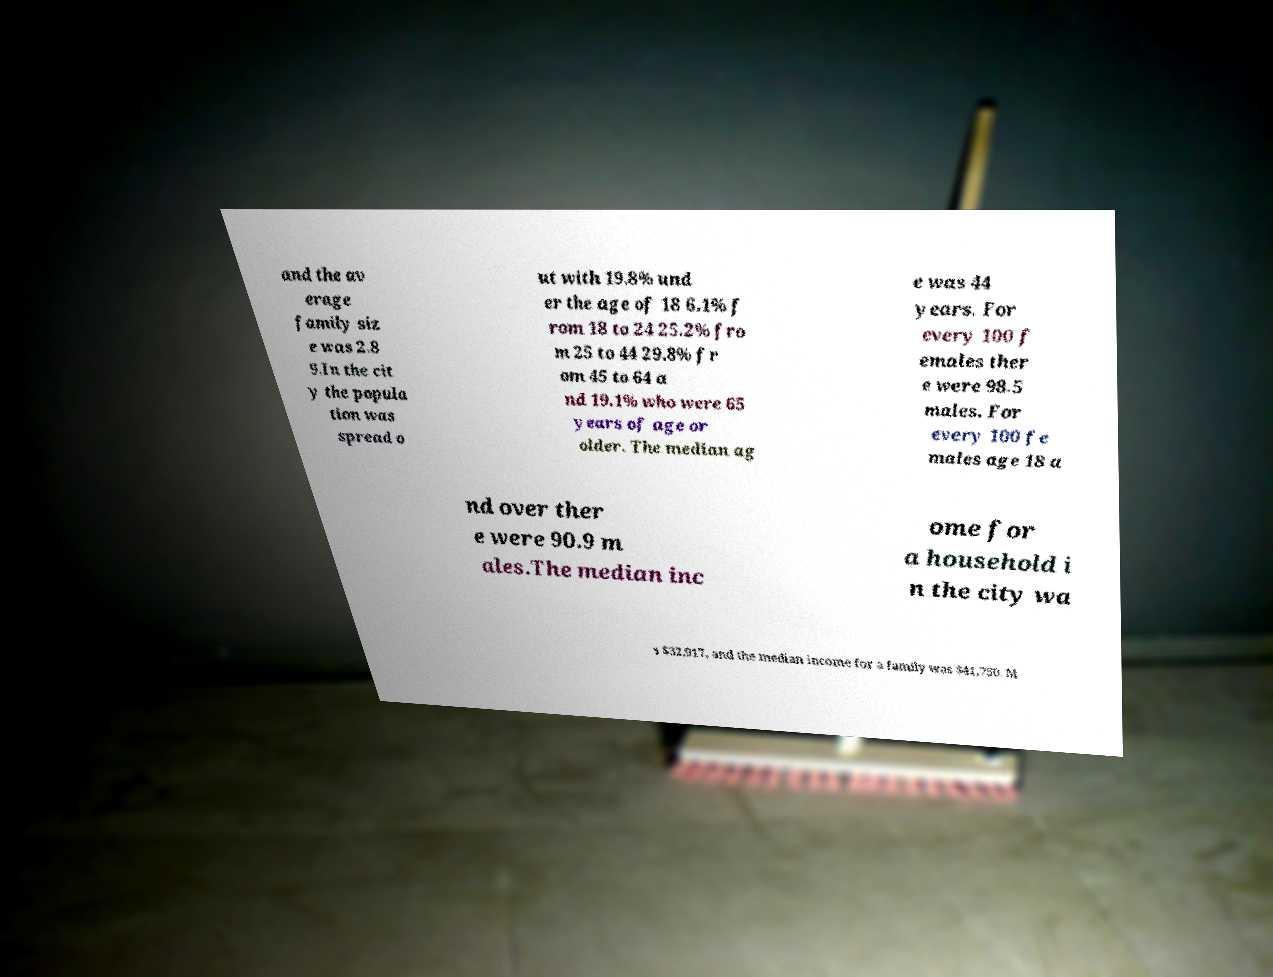There's text embedded in this image that I need extracted. Can you transcribe it verbatim? and the av erage family siz e was 2.8 9.In the cit y the popula tion was spread o ut with 19.8% und er the age of 18 6.1% f rom 18 to 24 25.2% fro m 25 to 44 29.8% fr om 45 to 64 a nd 19.1% who were 65 years of age or older. The median ag e was 44 years. For every 100 f emales ther e were 98.5 males. For every 100 fe males age 18 a nd over ther e were 90.9 m ales.The median inc ome for a household i n the city wa s $32,917, and the median income for a family was $41,750. M 